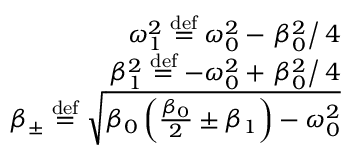<formula> <loc_0><loc_0><loc_500><loc_500>\begin{array} { r } { \omega _ { 1 } ^ { 2 } \stackrel { d e f } { = } \omega _ { 0 } ^ { 2 } - \beta _ { 0 } ^ { 2 } \right / 4 } \\ { \beta _ { 1 } ^ { 2 } \stackrel { d e f } { = } - \omega _ { 0 } ^ { 2 } + \beta _ { 0 } ^ { 2 } \right / 4 } \\ { \beta _ { \pm } \stackrel { d e f } { = } \sqrt { \beta _ { 0 } \left ( \frac { \beta _ { 0 } } { 2 } \pm \beta _ { 1 } \right ) - \omega _ { 0 } ^ { 2 } } } \end{array}</formula> 